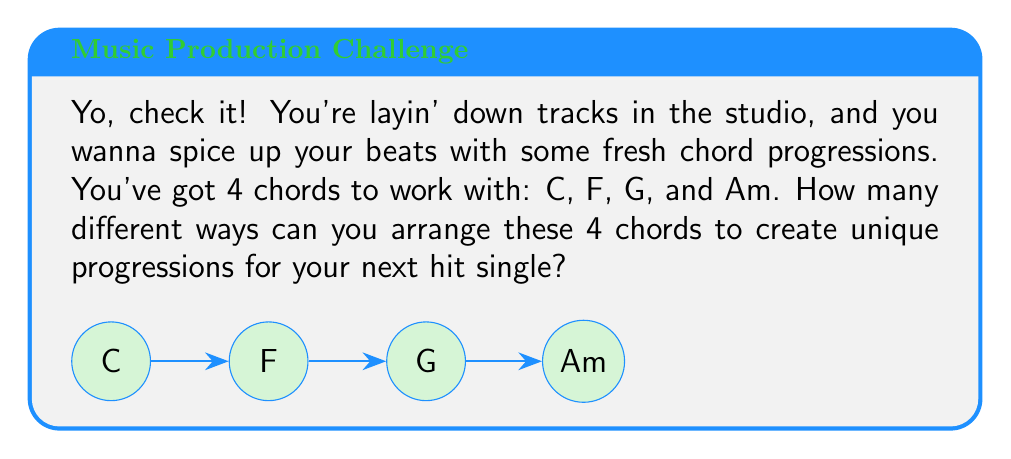Provide a solution to this math problem. Alright, let's break this down:

1) We're dealing with permutations here. We want to know how many ways we can arrange 4 distinct chords.

2) In permutation theory, this is represented by $n!$, where $n$ is the number of elements we're arranging.

3) In this case, $n = 4$ (C, F, G, and Am).

4) So, we need to calculate $4!$

5) Let's break that down:
   $4! = 4 \times 3 \times 2 \times 1$

6) Computing this:
   $4! = 24$

7) Each of these 24 permutations represents a unique chord progression.

For example, some of these progressions could be:
- C-F-G-Am
- Am-G-F-C
- G-C-Am-F
... and 21 more!

This concept in group theory is related to the symmetric group $S_4$, which contains all permutations of 4 elements.
Answer: 24 